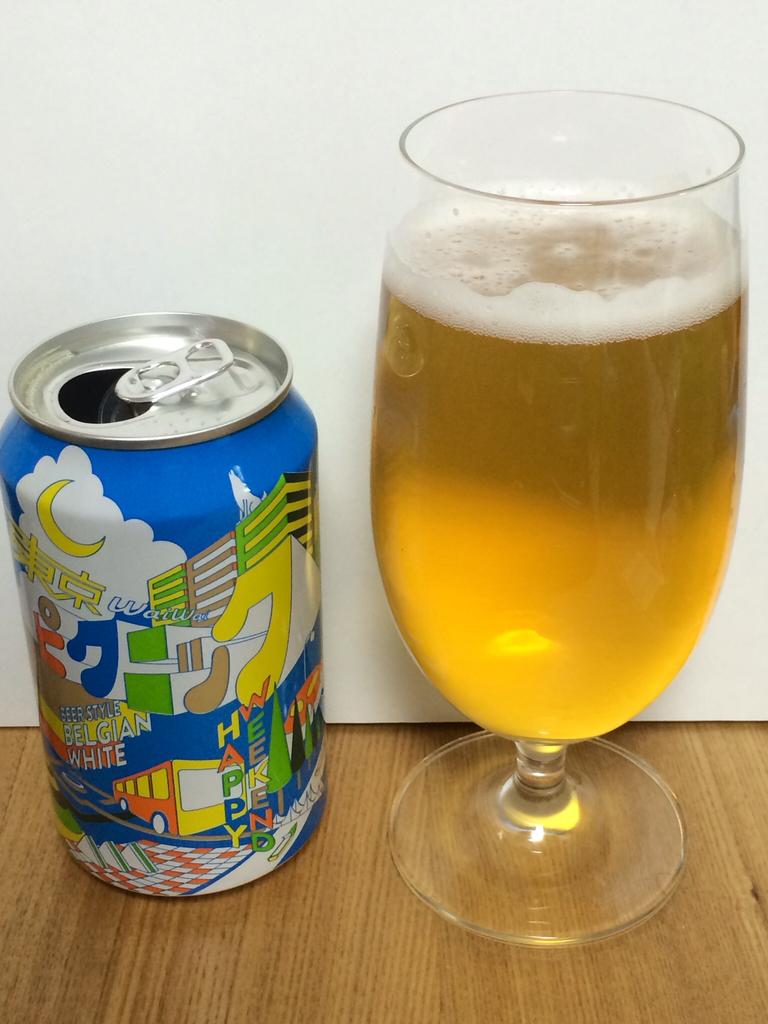What kind of weekend is it?
Give a very brief answer. Happy. 